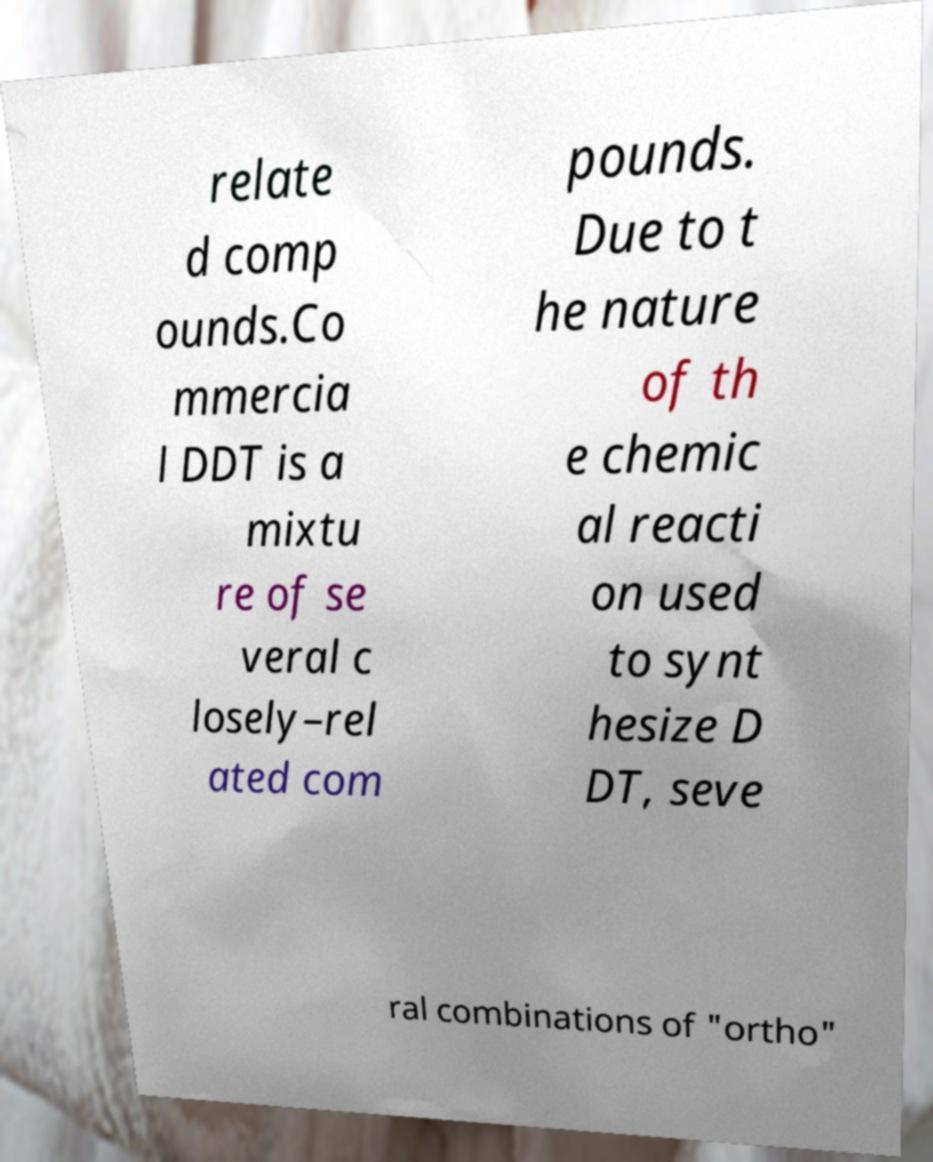For documentation purposes, I need the text within this image transcribed. Could you provide that? relate d comp ounds.Co mmercia l DDT is a mixtu re of se veral c losely–rel ated com pounds. Due to t he nature of th e chemic al reacti on used to synt hesize D DT, seve ral combinations of "ortho" 